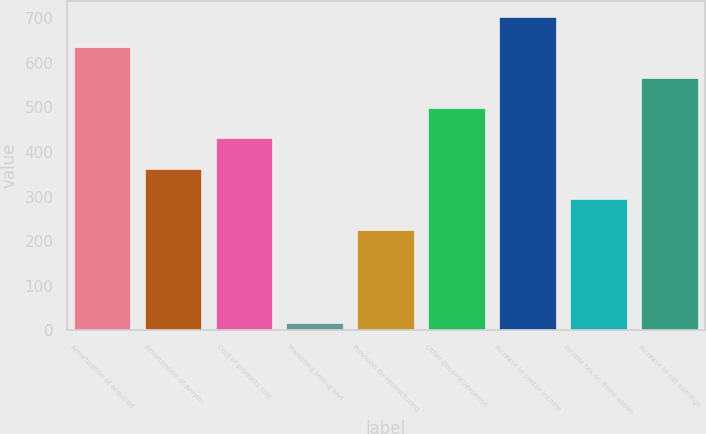Convert chart to OTSL. <chart><loc_0><loc_0><loc_500><loc_500><bar_chart><fcel>Amortization of acquired<fcel>Amortization of Amylin<fcel>Cost of products sold<fcel>Marketing selling and<fcel>Provision for restructuring<fcel>Other (income)/expense<fcel>Increase to pretax income<fcel>Income tax on items above<fcel>Increase to net earnings<nl><fcel>635.2<fcel>362.4<fcel>430.6<fcel>16<fcel>226<fcel>498.8<fcel>703.4<fcel>294.2<fcel>567<nl></chart> 